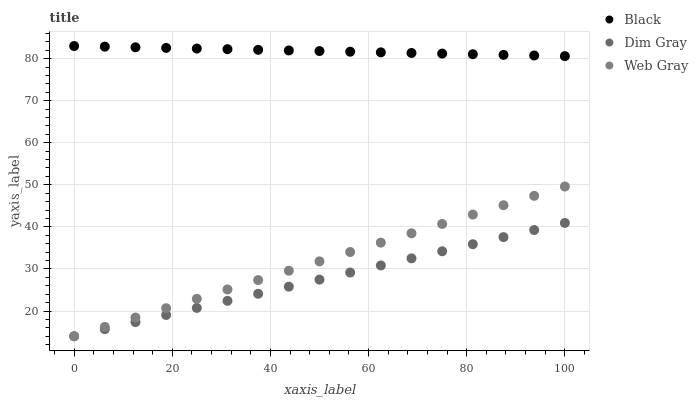Does Dim Gray have the minimum area under the curve?
Answer yes or no. Yes. Does Black have the maximum area under the curve?
Answer yes or no. Yes. Does Black have the minimum area under the curve?
Answer yes or no. No. Does Dim Gray have the maximum area under the curve?
Answer yes or no. No. Is Dim Gray the smoothest?
Answer yes or no. Yes. Is Black the roughest?
Answer yes or no. Yes. Is Black the smoothest?
Answer yes or no. No. Is Dim Gray the roughest?
Answer yes or no. No. Does Web Gray have the lowest value?
Answer yes or no. Yes. Does Black have the lowest value?
Answer yes or no. No. Does Black have the highest value?
Answer yes or no. Yes. Does Dim Gray have the highest value?
Answer yes or no. No. Is Web Gray less than Black?
Answer yes or no. Yes. Is Black greater than Web Gray?
Answer yes or no. Yes. Does Dim Gray intersect Web Gray?
Answer yes or no. Yes. Is Dim Gray less than Web Gray?
Answer yes or no. No. Is Dim Gray greater than Web Gray?
Answer yes or no. No. Does Web Gray intersect Black?
Answer yes or no. No. 